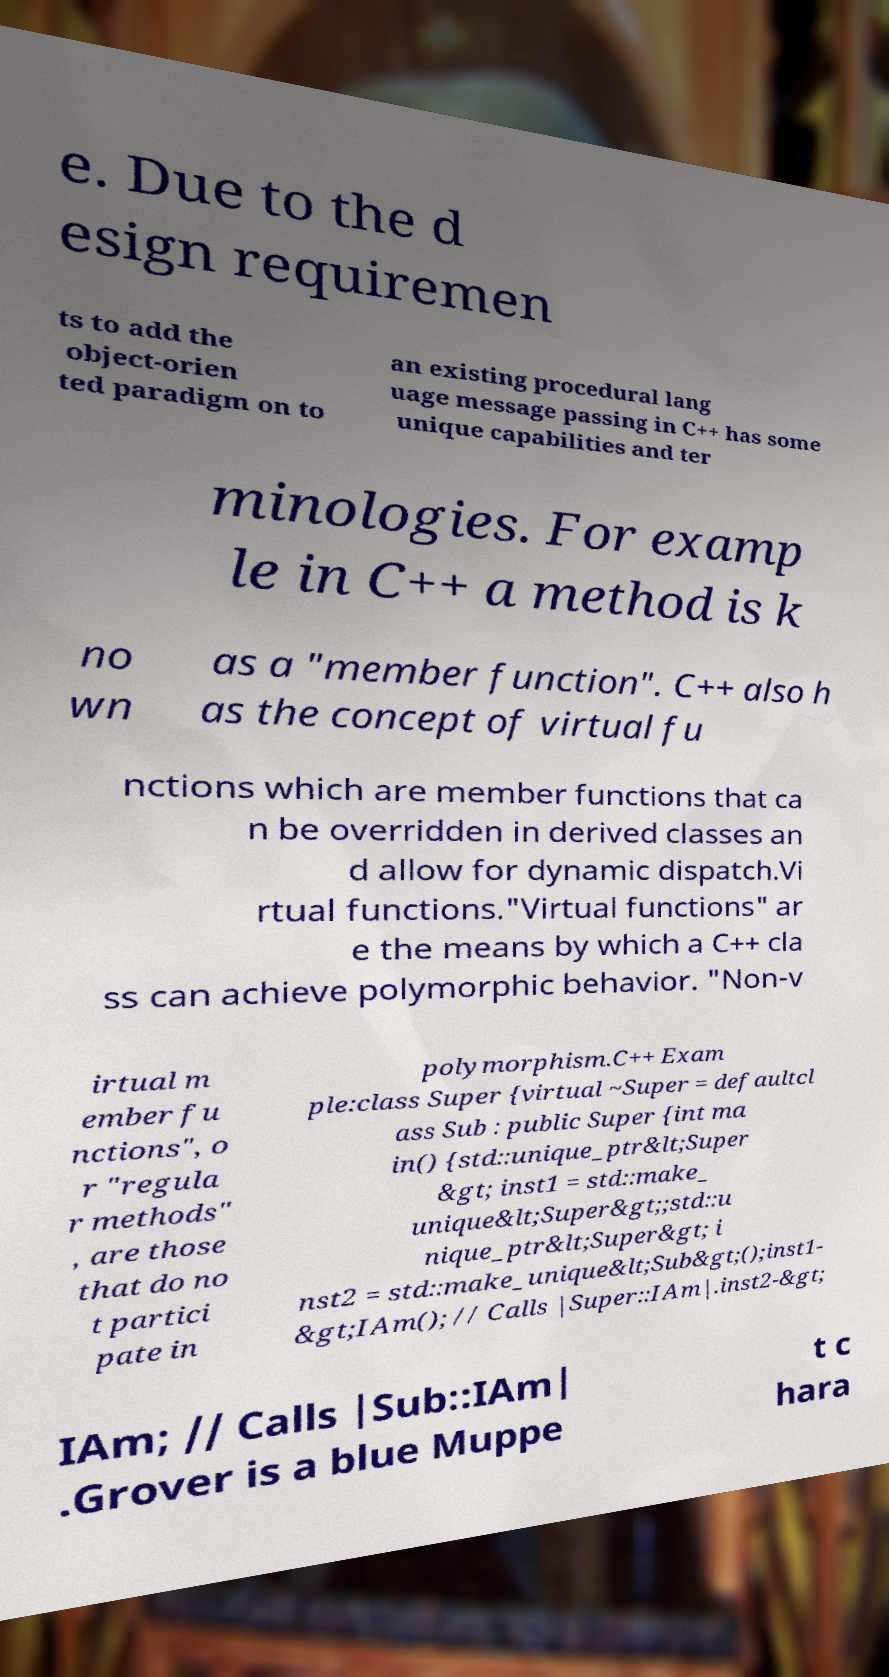I need the written content from this picture converted into text. Can you do that? e. Due to the d esign requiremen ts to add the object-orien ted paradigm on to an existing procedural lang uage message passing in C++ has some unique capabilities and ter minologies. For examp le in C++ a method is k no wn as a "member function". C++ also h as the concept of virtual fu nctions which are member functions that ca n be overridden in derived classes an d allow for dynamic dispatch.Vi rtual functions."Virtual functions" ar e the means by which a C++ cla ss can achieve polymorphic behavior. "Non-v irtual m ember fu nctions", o r "regula r methods" , are those that do no t partici pate in polymorphism.C++ Exam ple:class Super {virtual ~Super = defaultcl ass Sub : public Super {int ma in() {std::unique_ptr&lt;Super &gt; inst1 = std::make_ unique&lt;Super&gt;;std::u nique_ptr&lt;Super&gt; i nst2 = std::make_unique&lt;Sub&gt;();inst1- &gt;IAm(); // Calls |Super::IAm|.inst2-&gt; IAm; // Calls |Sub::IAm| .Grover is a blue Muppe t c hara 